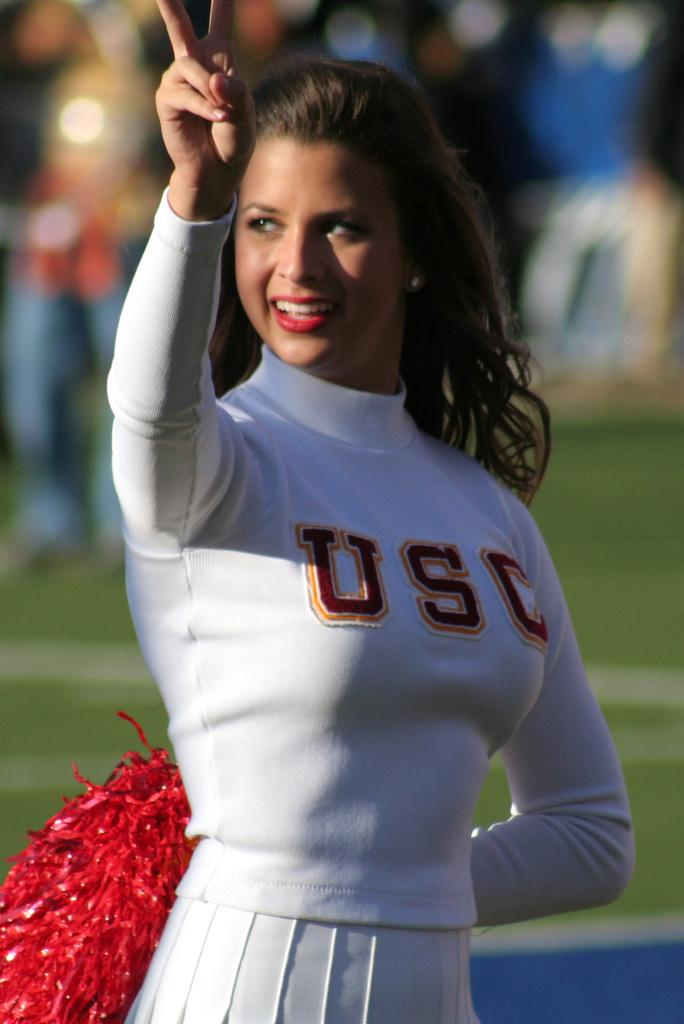<image>
Create a compact narrative representing the image presented. A brunette USC cheerleader in white holds up her "no 1" finger. 